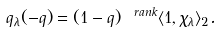<formula> <loc_0><loc_0><loc_500><loc_500>\ q _ { \lambda } ( - q ) = ( 1 - q ) ^ { \ r a n k } \langle 1 , \chi _ { \lambda } \rangle _ { 2 } .</formula> 